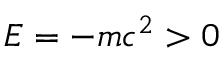Convert formula to latex. <formula><loc_0><loc_0><loc_500><loc_500>E = - m c ^ { 2 } > 0</formula> 